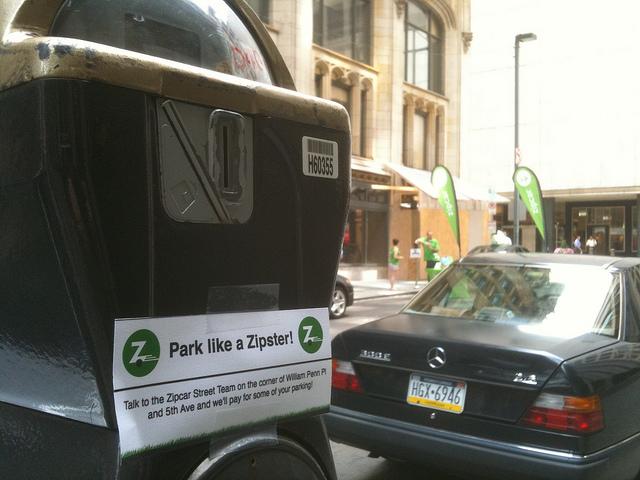What does the license plate say?
Answer briefly. Hgx 6946. Is there a building in the upper right corner?
Quick response, please. Yes. Who is advertising on the parking meter?
Concise answer only. Zipster. 